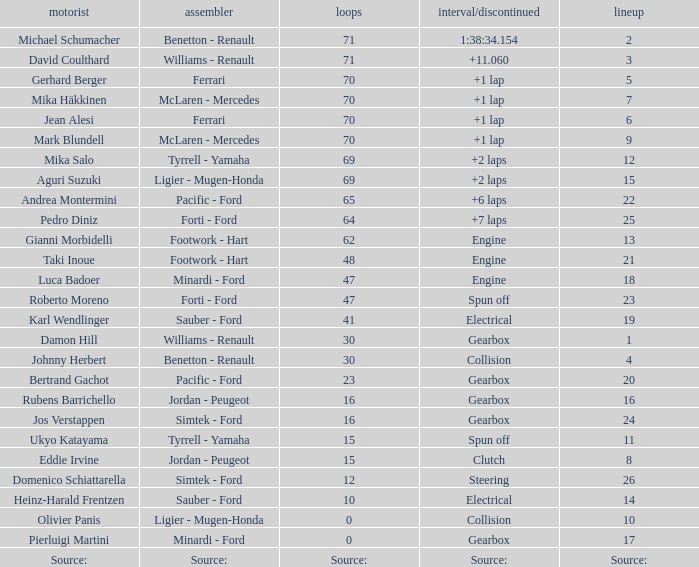David Coulthard was the driver in which grid? 3.0. 